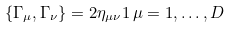<formula> <loc_0><loc_0><loc_500><loc_500>\{ \Gamma _ { \mu } , \Gamma _ { \nu } \} = 2 \eta _ { \mu \nu } { 1 } \, \mu = 1 , \dots , D</formula> 